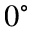Convert formula to latex. <formula><loc_0><loc_0><loc_500><loc_500>0 ^ { \circ }</formula> 